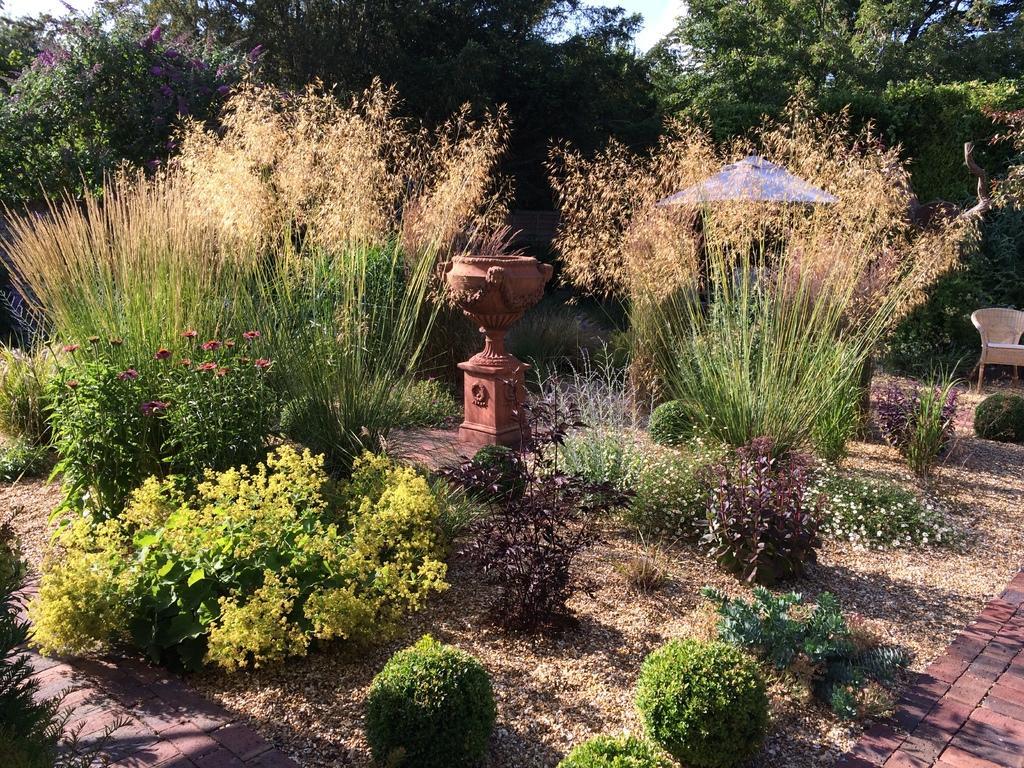Describe this image in one or two sentences. In this picture there is a flower pot and there is an umbrella and there is a chair and there are trees and plants. At the top there is sky. At the bottom there is a pavement and there is ground. 